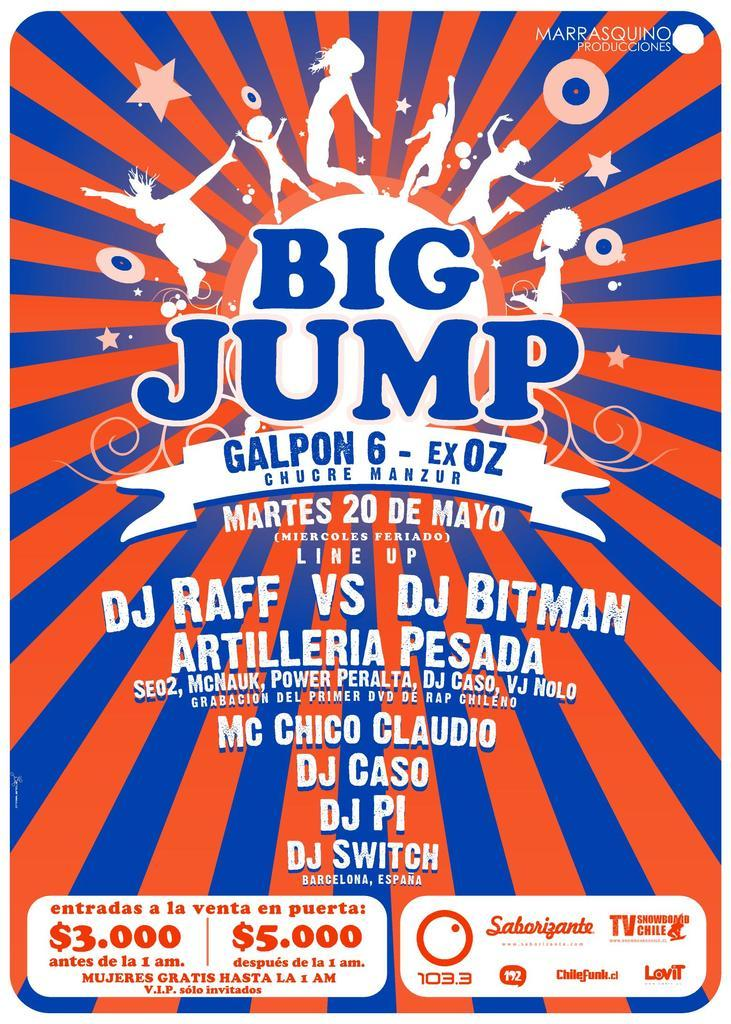Provide a one-sentence caption for the provided image. A poster about the Big Jump Galpon 6 - Ex OZ event on Martes 20 De Mayo. 